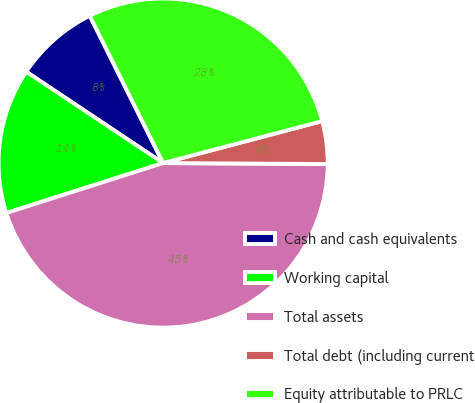<chart> <loc_0><loc_0><loc_500><loc_500><pie_chart><fcel>Cash and cash equivalents<fcel>Working capital<fcel>Total assets<fcel>Total debt (including current<fcel>Equity attributable to PRLC<nl><fcel>8.28%<fcel>14.28%<fcel>45.0%<fcel>4.2%<fcel>28.25%<nl></chart> 